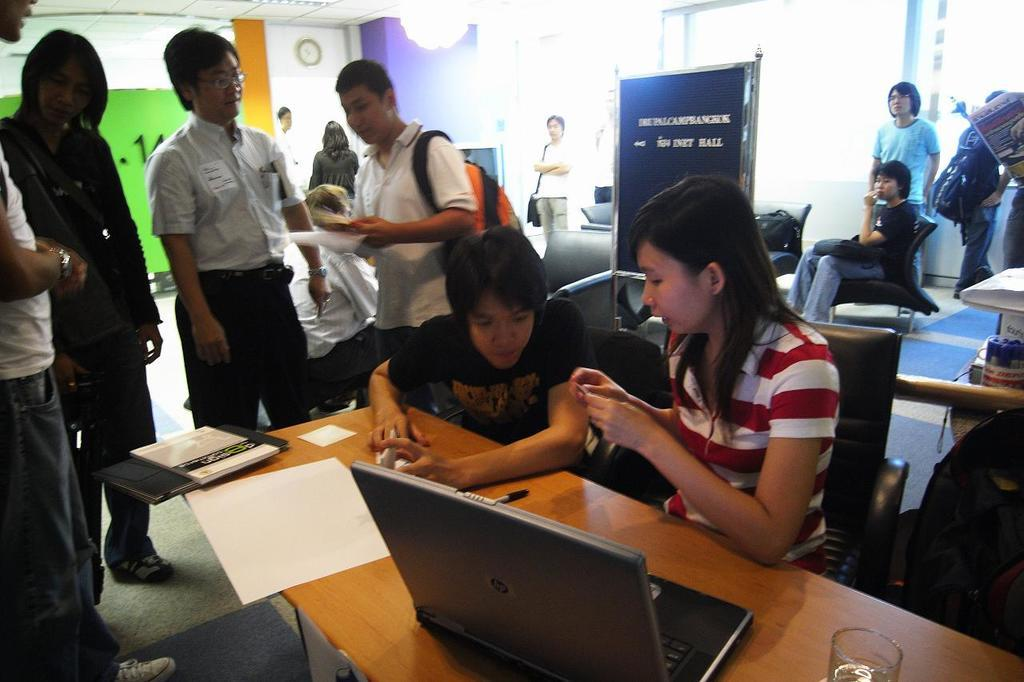Where was the image taken? The image was taken in a room. What are the two persons near the table doing? The two persons are sitting near a table in the center of the room. Can you describe the background of the image? In the background, there is a group of people, a board, lights, and a window. What type of creature can be seen drinking from a cup in the image? There is no creature present in the image, and no cup is visible either. 